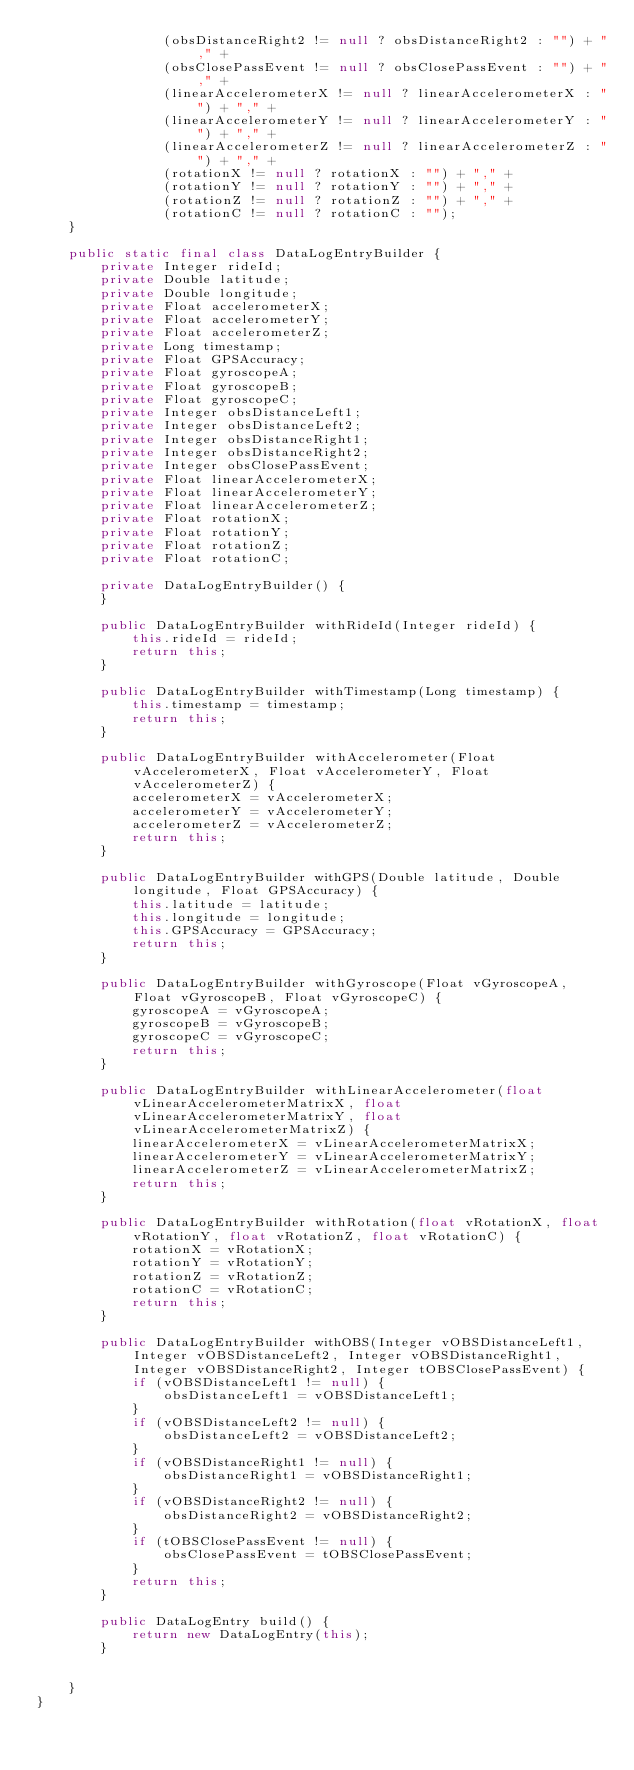<code> <loc_0><loc_0><loc_500><loc_500><_Java_>                (obsDistanceRight2 != null ? obsDistanceRight2 : "") + "," +
                (obsClosePassEvent != null ? obsClosePassEvent : "") + "," +
                (linearAccelerometerX != null ? linearAccelerometerX : "") + "," +
                (linearAccelerometerY != null ? linearAccelerometerY : "") + "," +
                (linearAccelerometerZ != null ? linearAccelerometerZ : "") + "," +
                (rotationX != null ? rotationX : "") + "," +
                (rotationY != null ? rotationY : "") + "," +
                (rotationZ != null ? rotationZ : "") + "," +
                (rotationC != null ? rotationC : "");
    }

    public static final class DataLogEntryBuilder {
        private Integer rideId;
        private Double latitude;
        private Double longitude;
        private Float accelerometerX;
        private Float accelerometerY;
        private Float accelerometerZ;
        private Long timestamp;
        private Float GPSAccuracy;
        private Float gyroscopeA;
        private Float gyroscopeB;
        private Float gyroscopeC;
        private Integer obsDistanceLeft1;
        private Integer obsDistanceLeft2;
        private Integer obsDistanceRight1;
        private Integer obsDistanceRight2;
        private Integer obsClosePassEvent;
        private Float linearAccelerometerX;
        private Float linearAccelerometerY;
        private Float linearAccelerometerZ;
        private Float rotationX;
        private Float rotationY;
        private Float rotationZ;
        private Float rotationC;

        private DataLogEntryBuilder() {
        }

        public DataLogEntryBuilder withRideId(Integer rideId) {
            this.rideId = rideId;
            return this;
        }

        public DataLogEntryBuilder withTimestamp(Long timestamp) {
            this.timestamp = timestamp;
            return this;
        }

        public DataLogEntryBuilder withAccelerometer(Float vAccelerometerX, Float vAccelerometerY, Float vAccelerometerZ) {
            accelerometerX = vAccelerometerX;
            accelerometerY = vAccelerometerY;
            accelerometerZ = vAccelerometerZ;
            return this;
        }

        public DataLogEntryBuilder withGPS(Double latitude, Double longitude, Float GPSAccuracy) {
            this.latitude = latitude;
            this.longitude = longitude;
            this.GPSAccuracy = GPSAccuracy;
            return this;
        }

        public DataLogEntryBuilder withGyroscope(Float vGyroscopeA, Float vGyroscopeB, Float vGyroscopeC) {
            gyroscopeA = vGyroscopeA;
            gyroscopeB = vGyroscopeB;
            gyroscopeC = vGyroscopeC;
            return this;
        }

        public DataLogEntryBuilder withLinearAccelerometer(float vLinearAccelerometerMatrixX, float vLinearAccelerometerMatrixY, float vLinearAccelerometerMatrixZ) {
            linearAccelerometerX = vLinearAccelerometerMatrixX;
            linearAccelerometerY = vLinearAccelerometerMatrixY;
            linearAccelerometerZ = vLinearAccelerometerMatrixZ;
            return this;
        }

        public DataLogEntryBuilder withRotation(float vRotationX, float vRotationY, float vRotationZ, float vRotationC) {
            rotationX = vRotationX;
            rotationY = vRotationY;
            rotationZ = vRotationZ;
            rotationC = vRotationC;
            return this;
        }

        public DataLogEntryBuilder withOBS(Integer vOBSDistanceLeft1, Integer vOBSDistanceLeft2, Integer vOBSDistanceRight1, Integer vOBSDistanceRight2, Integer tOBSClosePassEvent) {
            if (vOBSDistanceLeft1 != null) {
                obsDistanceLeft1 = vOBSDistanceLeft1;
            }
            if (vOBSDistanceLeft2 != null) {
                obsDistanceLeft2 = vOBSDistanceLeft2;
            }
            if (vOBSDistanceRight1 != null) {
                obsDistanceRight1 = vOBSDistanceRight1;
            }
            if (vOBSDistanceRight2 != null) {
                obsDistanceRight2 = vOBSDistanceRight2;
            }
            if (tOBSClosePassEvent != null) {
                obsClosePassEvent = tOBSClosePassEvent;
            }
            return this;
        }

        public DataLogEntry build() {
            return new DataLogEntry(this);
        }


    }
}
</code> 